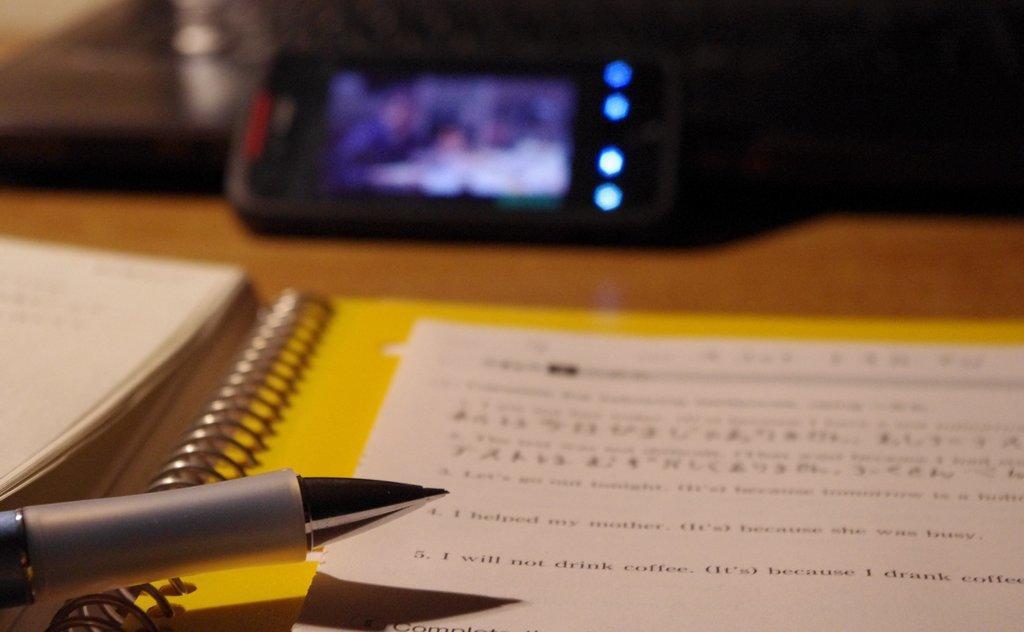Can you describe this image briefly? In this picture we can see a table. On the table we can see a mobile, file, book, paper and pen. At the top, the image is blur. 